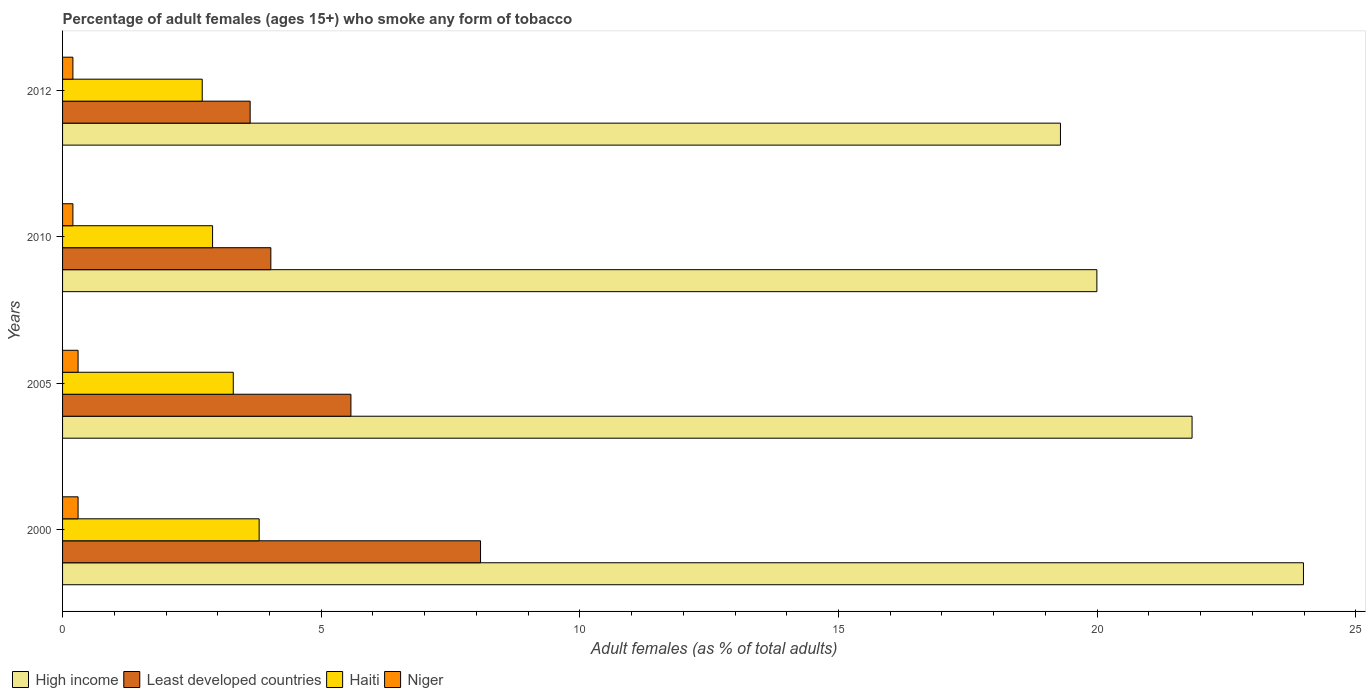How many different coloured bars are there?
Your response must be concise. 4. How many groups of bars are there?
Offer a very short reply. 4. Are the number of bars per tick equal to the number of legend labels?
Your answer should be very brief. Yes. Are the number of bars on each tick of the Y-axis equal?
Your answer should be very brief. Yes. What is the total percentage of adult females who smoke in Least developed countries in the graph?
Offer a very short reply. 21.31. What is the difference between the percentage of adult females who smoke in High income in 2010 and that in 2012?
Your answer should be compact. 0.7. What is the difference between the percentage of adult females who smoke in Least developed countries in 2010 and the percentage of adult females who smoke in Niger in 2000?
Your answer should be very brief. 3.73. What is the average percentage of adult females who smoke in Least developed countries per year?
Your response must be concise. 5.33. In the year 2010, what is the difference between the percentage of adult females who smoke in High income and percentage of adult females who smoke in Least developed countries?
Make the answer very short. 15.97. What is the ratio of the percentage of adult females who smoke in Least developed countries in 2000 to that in 2010?
Make the answer very short. 2.01. Is the percentage of adult females who smoke in Least developed countries in 2000 less than that in 2010?
Provide a succinct answer. No. What is the difference between the highest and the second highest percentage of adult females who smoke in High income?
Offer a terse response. 2.15. What is the difference between the highest and the lowest percentage of adult females who smoke in High income?
Your response must be concise. 4.7. In how many years, is the percentage of adult females who smoke in Haiti greater than the average percentage of adult females who smoke in Haiti taken over all years?
Offer a very short reply. 2. Is the sum of the percentage of adult females who smoke in Haiti in 2000 and 2010 greater than the maximum percentage of adult females who smoke in Niger across all years?
Keep it short and to the point. Yes. What does the 1st bar from the top in 2010 represents?
Offer a very short reply. Niger. What does the 4th bar from the bottom in 2010 represents?
Your answer should be compact. Niger. Is it the case that in every year, the sum of the percentage of adult females who smoke in High income and percentage of adult females who smoke in Least developed countries is greater than the percentage of adult females who smoke in Niger?
Your answer should be compact. Yes. Are the values on the major ticks of X-axis written in scientific E-notation?
Ensure brevity in your answer.  No. Does the graph contain any zero values?
Offer a very short reply. No. Does the graph contain grids?
Provide a succinct answer. No. Where does the legend appear in the graph?
Offer a terse response. Bottom left. How many legend labels are there?
Offer a very short reply. 4. What is the title of the graph?
Keep it short and to the point. Percentage of adult females (ages 15+) who smoke any form of tobacco. What is the label or title of the X-axis?
Offer a terse response. Adult females (as % of total adults). What is the Adult females (as % of total adults) in High income in 2000?
Provide a succinct answer. 23.99. What is the Adult females (as % of total adults) in Least developed countries in 2000?
Make the answer very short. 8.08. What is the Adult females (as % of total adults) in Niger in 2000?
Offer a terse response. 0.3. What is the Adult females (as % of total adults) in High income in 2005?
Your response must be concise. 21.83. What is the Adult females (as % of total adults) of Least developed countries in 2005?
Offer a very short reply. 5.57. What is the Adult females (as % of total adults) of Haiti in 2005?
Offer a very short reply. 3.3. What is the Adult females (as % of total adults) of High income in 2010?
Provide a short and direct response. 19.99. What is the Adult females (as % of total adults) in Least developed countries in 2010?
Offer a very short reply. 4.03. What is the Adult females (as % of total adults) in Haiti in 2010?
Ensure brevity in your answer.  2.9. What is the Adult females (as % of total adults) of Niger in 2010?
Give a very brief answer. 0.2. What is the Adult females (as % of total adults) in High income in 2012?
Your answer should be compact. 19.29. What is the Adult females (as % of total adults) of Least developed countries in 2012?
Make the answer very short. 3.63. What is the Adult females (as % of total adults) in Haiti in 2012?
Make the answer very short. 2.7. Across all years, what is the maximum Adult females (as % of total adults) in High income?
Your response must be concise. 23.99. Across all years, what is the maximum Adult females (as % of total adults) in Least developed countries?
Ensure brevity in your answer.  8.08. Across all years, what is the minimum Adult females (as % of total adults) of High income?
Offer a terse response. 19.29. Across all years, what is the minimum Adult females (as % of total adults) of Least developed countries?
Make the answer very short. 3.63. Across all years, what is the minimum Adult females (as % of total adults) of Haiti?
Provide a succinct answer. 2.7. Across all years, what is the minimum Adult females (as % of total adults) in Niger?
Your response must be concise. 0.2. What is the total Adult females (as % of total adults) in High income in the graph?
Offer a terse response. 85.11. What is the total Adult females (as % of total adults) of Least developed countries in the graph?
Your response must be concise. 21.31. What is the difference between the Adult females (as % of total adults) of High income in 2000 and that in 2005?
Provide a succinct answer. 2.15. What is the difference between the Adult females (as % of total adults) in Least developed countries in 2000 and that in 2005?
Give a very brief answer. 2.51. What is the difference between the Adult females (as % of total adults) of Haiti in 2000 and that in 2005?
Your answer should be very brief. 0.5. What is the difference between the Adult females (as % of total adults) in High income in 2000 and that in 2010?
Make the answer very short. 3.99. What is the difference between the Adult females (as % of total adults) in Least developed countries in 2000 and that in 2010?
Keep it short and to the point. 4.05. What is the difference between the Adult females (as % of total adults) of Haiti in 2000 and that in 2010?
Provide a short and direct response. 0.9. What is the difference between the Adult females (as % of total adults) in Niger in 2000 and that in 2010?
Offer a terse response. 0.1. What is the difference between the Adult females (as % of total adults) of High income in 2000 and that in 2012?
Give a very brief answer. 4.7. What is the difference between the Adult females (as % of total adults) of Least developed countries in 2000 and that in 2012?
Offer a terse response. 4.45. What is the difference between the Adult females (as % of total adults) in High income in 2005 and that in 2010?
Offer a terse response. 1.84. What is the difference between the Adult females (as % of total adults) of Least developed countries in 2005 and that in 2010?
Keep it short and to the point. 1.55. What is the difference between the Adult females (as % of total adults) in Haiti in 2005 and that in 2010?
Offer a terse response. 0.4. What is the difference between the Adult females (as % of total adults) in Niger in 2005 and that in 2010?
Offer a very short reply. 0.1. What is the difference between the Adult females (as % of total adults) in High income in 2005 and that in 2012?
Your answer should be very brief. 2.54. What is the difference between the Adult females (as % of total adults) in Least developed countries in 2005 and that in 2012?
Provide a succinct answer. 1.95. What is the difference between the Adult females (as % of total adults) in High income in 2010 and that in 2012?
Offer a terse response. 0.7. What is the difference between the Adult females (as % of total adults) in Least developed countries in 2010 and that in 2012?
Offer a very short reply. 0.4. What is the difference between the Adult females (as % of total adults) of Haiti in 2010 and that in 2012?
Provide a short and direct response. 0.2. What is the difference between the Adult females (as % of total adults) in Niger in 2010 and that in 2012?
Your response must be concise. 0. What is the difference between the Adult females (as % of total adults) of High income in 2000 and the Adult females (as % of total adults) of Least developed countries in 2005?
Provide a short and direct response. 18.41. What is the difference between the Adult females (as % of total adults) of High income in 2000 and the Adult females (as % of total adults) of Haiti in 2005?
Your answer should be very brief. 20.69. What is the difference between the Adult females (as % of total adults) in High income in 2000 and the Adult females (as % of total adults) in Niger in 2005?
Your response must be concise. 23.69. What is the difference between the Adult females (as % of total adults) of Least developed countries in 2000 and the Adult females (as % of total adults) of Haiti in 2005?
Your answer should be compact. 4.78. What is the difference between the Adult females (as % of total adults) in Least developed countries in 2000 and the Adult females (as % of total adults) in Niger in 2005?
Your response must be concise. 7.78. What is the difference between the Adult females (as % of total adults) in High income in 2000 and the Adult females (as % of total adults) in Least developed countries in 2010?
Offer a terse response. 19.96. What is the difference between the Adult females (as % of total adults) of High income in 2000 and the Adult females (as % of total adults) of Haiti in 2010?
Offer a very short reply. 21.09. What is the difference between the Adult females (as % of total adults) in High income in 2000 and the Adult females (as % of total adults) in Niger in 2010?
Offer a terse response. 23.79. What is the difference between the Adult females (as % of total adults) in Least developed countries in 2000 and the Adult females (as % of total adults) in Haiti in 2010?
Keep it short and to the point. 5.18. What is the difference between the Adult females (as % of total adults) of Least developed countries in 2000 and the Adult females (as % of total adults) of Niger in 2010?
Provide a short and direct response. 7.88. What is the difference between the Adult females (as % of total adults) in Haiti in 2000 and the Adult females (as % of total adults) in Niger in 2010?
Provide a short and direct response. 3.6. What is the difference between the Adult females (as % of total adults) of High income in 2000 and the Adult females (as % of total adults) of Least developed countries in 2012?
Provide a short and direct response. 20.36. What is the difference between the Adult females (as % of total adults) of High income in 2000 and the Adult females (as % of total adults) of Haiti in 2012?
Your answer should be compact. 21.29. What is the difference between the Adult females (as % of total adults) in High income in 2000 and the Adult females (as % of total adults) in Niger in 2012?
Your response must be concise. 23.79. What is the difference between the Adult females (as % of total adults) in Least developed countries in 2000 and the Adult females (as % of total adults) in Haiti in 2012?
Make the answer very short. 5.38. What is the difference between the Adult females (as % of total adults) in Least developed countries in 2000 and the Adult females (as % of total adults) in Niger in 2012?
Make the answer very short. 7.88. What is the difference between the Adult females (as % of total adults) of High income in 2005 and the Adult females (as % of total adults) of Least developed countries in 2010?
Provide a succinct answer. 17.81. What is the difference between the Adult females (as % of total adults) in High income in 2005 and the Adult females (as % of total adults) in Haiti in 2010?
Offer a very short reply. 18.93. What is the difference between the Adult females (as % of total adults) in High income in 2005 and the Adult females (as % of total adults) in Niger in 2010?
Provide a succinct answer. 21.63. What is the difference between the Adult females (as % of total adults) in Least developed countries in 2005 and the Adult females (as % of total adults) in Haiti in 2010?
Make the answer very short. 2.67. What is the difference between the Adult females (as % of total adults) in Least developed countries in 2005 and the Adult females (as % of total adults) in Niger in 2010?
Your answer should be compact. 5.37. What is the difference between the Adult females (as % of total adults) in High income in 2005 and the Adult females (as % of total adults) in Least developed countries in 2012?
Ensure brevity in your answer.  18.21. What is the difference between the Adult females (as % of total adults) in High income in 2005 and the Adult females (as % of total adults) in Haiti in 2012?
Your answer should be compact. 19.13. What is the difference between the Adult females (as % of total adults) of High income in 2005 and the Adult females (as % of total adults) of Niger in 2012?
Give a very brief answer. 21.63. What is the difference between the Adult females (as % of total adults) in Least developed countries in 2005 and the Adult females (as % of total adults) in Haiti in 2012?
Offer a terse response. 2.87. What is the difference between the Adult females (as % of total adults) of Least developed countries in 2005 and the Adult females (as % of total adults) of Niger in 2012?
Provide a succinct answer. 5.37. What is the difference between the Adult females (as % of total adults) in Haiti in 2005 and the Adult females (as % of total adults) in Niger in 2012?
Offer a terse response. 3.1. What is the difference between the Adult females (as % of total adults) in High income in 2010 and the Adult females (as % of total adults) in Least developed countries in 2012?
Offer a terse response. 16.37. What is the difference between the Adult females (as % of total adults) in High income in 2010 and the Adult females (as % of total adults) in Haiti in 2012?
Ensure brevity in your answer.  17.29. What is the difference between the Adult females (as % of total adults) in High income in 2010 and the Adult females (as % of total adults) in Niger in 2012?
Make the answer very short. 19.79. What is the difference between the Adult females (as % of total adults) in Least developed countries in 2010 and the Adult females (as % of total adults) in Haiti in 2012?
Your response must be concise. 1.33. What is the difference between the Adult females (as % of total adults) of Least developed countries in 2010 and the Adult females (as % of total adults) of Niger in 2012?
Offer a very short reply. 3.83. What is the difference between the Adult females (as % of total adults) in Haiti in 2010 and the Adult females (as % of total adults) in Niger in 2012?
Make the answer very short. 2.7. What is the average Adult females (as % of total adults) of High income per year?
Give a very brief answer. 21.28. What is the average Adult females (as % of total adults) in Least developed countries per year?
Offer a very short reply. 5.33. What is the average Adult females (as % of total adults) of Haiti per year?
Make the answer very short. 3.17. What is the average Adult females (as % of total adults) of Niger per year?
Keep it short and to the point. 0.25. In the year 2000, what is the difference between the Adult females (as % of total adults) of High income and Adult females (as % of total adults) of Least developed countries?
Offer a very short reply. 15.91. In the year 2000, what is the difference between the Adult females (as % of total adults) in High income and Adult females (as % of total adults) in Haiti?
Keep it short and to the point. 20.19. In the year 2000, what is the difference between the Adult females (as % of total adults) of High income and Adult females (as % of total adults) of Niger?
Your response must be concise. 23.69. In the year 2000, what is the difference between the Adult females (as % of total adults) of Least developed countries and Adult females (as % of total adults) of Haiti?
Offer a very short reply. 4.28. In the year 2000, what is the difference between the Adult females (as % of total adults) in Least developed countries and Adult females (as % of total adults) in Niger?
Offer a very short reply. 7.78. In the year 2000, what is the difference between the Adult females (as % of total adults) of Haiti and Adult females (as % of total adults) of Niger?
Keep it short and to the point. 3.5. In the year 2005, what is the difference between the Adult females (as % of total adults) in High income and Adult females (as % of total adults) in Least developed countries?
Give a very brief answer. 16.26. In the year 2005, what is the difference between the Adult females (as % of total adults) of High income and Adult females (as % of total adults) of Haiti?
Make the answer very short. 18.53. In the year 2005, what is the difference between the Adult females (as % of total adults) of High income and Adult females (as % of total adults) of Niger?
Provide a succinct answer. 21.53. In the year 2005, what is the difference between the Adult females (as % of total adults) of Least developed countries and Adult females (as % of total adults) of Haiti?
Keep it short and to the point. 2.27. In the year 2005, what is the difference between the Adult females (as % of total adults) in Least developed countries and Adult females (as % of total adults) in Niger?
Keep it short and to the point. 5.27. In the year 2010, what is the difference between the Adult females (as % of total adults) in High income and Adult females (as % of total adults) in Least developed countries?
Give a very brief answer. 15.97. In the year 2010, what is the difference between the Adult females (as % of total adults) of High income and Adult females (as % of total adults) of Haiti?
Offer a terse response. 17.09. In the year 2010, what is the difference between the Adult females (as % of total adults) in High income and Adult females (as % of total adults) in Niger?
Offer a very short reply. 19.79. In the year 2010, what is the difference between the Adult females (as % of total adults) in Least developed countries and Adult females (as % of total adults) in Haiti?
Give a very brief answer. 1.13. In the year 2010, what is the difference between the Adult females (as % of total adults) in Least developed countries and Adult females (as % of total adults) in Niger?
Offer a very short reply. 3.83. In the year 2010, what is the difference between the Adult females (as % of total adults) of Haiti and Adult females (as % of total adults) of Niger?
Give a very brief answer. 2.7. In the year 2012, what is the difference between the Adult females (as % of total adults) in High income and Adult females (as % of total adults) in Least developed countries?
Offer a terse response. 15.66. In the year 2012, what is the difference between the Adult females (as % of total adults) in High income and Adult females (as % of total adults) in Haiti?
Offer a very short reply. 16.59. In the year 2012, what is the difference between the Adult females (as % of total adults) in High income and Adult females (as % of total adults) in Niger?
Your answer should be very brief. 19.09. In the year 2012, what is the difference between the Adult females (as % of total adults) of Least developed countries and Adult females (as % of total adults) of Haiti?
Keep it short and to the point. 0.93. In the year 2012, what is the difference between the Adult females (as % of total adults) in Least developed countries and Adult females (as % of total adults) in Niger?
Your answer should be very brief. 3.43. What is the ratio of the Adult females (as % of total adults) of High income in 2000 to that in 2005?
Keep it short and to the point. 1.1. What is the ratio of the Adult females (as % of total adults) of Least developed countries in 2000 to that in 2005?
Give a very brief answer. 1.45. What is the ratio of the Adult females (as % of total adults) of Haiti in 2000 to that in 2005?
Ensure brevity in your answer.  1.15. What is the ratio of the Adult females (as % of total adults) of Niger in 2000 to that in 2005?
Provide a succinct answer. 1. What is the ratio of the Adult females (as % of total adults) of High income in 2000 to that in 2010?
Your answer should be compact. 1.2. What is the ratio of the Adult females (as % of total adults) in Least developed countries in 2000 to that in 2010?
Keep it short and to the point. 2.01. What is the ratio of the Adult females (as % of total adults) of Haiti in 2000 to that in 2010?
Provide a succinct answer. 1.31. What is the ratio of the Adult females (as % of total adults) in High income in 2000 to that in 2012?
Offer a very short reply. 1.24. What is the ratio of the Adult females (as % of total adults) in Least developed countries in 2000 to that in 2012?
Your answer should be compact. 2.23. What is the ratio of the Adult females (as % of total adults) in Haiti in 2000 to that in 2012?
Your answer should be very brief. 1.41. What is the ratio of the Adult females (as % of total adults) in High income in 2005 to that in 2010?
Provide a succinct answer. 1.09. What is the ratio of the Adult females (as % of total adults) of Least developed countries in 2005 to that in 2010?
Provide a short and direct response. 1.38. What is the ratio of the Adult females (as % of total adults) in Haiti in 2005 to that in 2010?
Offer a terse response. 1.14. What is the ratio of the Adult females (as % of total adults) in High income in 2005 to that in 2012?
Keep it short and to the point. 1.13. What is the ratio of the Adult females (as % of total adults) in Least developed countries in 2005 to that in 2012?
Keep it short and to the point. 1.54. What is the ratio of the Adult females (as % of total adults) in Haiti in 2005 to that in 2012?
Ensure brevity in your answer.  1.22. What is the ratio of the Adult females (as % of total adults) of High income in 2010 to that in 2012?
Ensure brevity in your answer.  1.04. What is the ratio of the Adult females (as % of total adults) in Least developed countries in 2010 to that in 2012?
Your answer should be compact. 1.11. What is the ratio of the Adult females (as % of total adults) in Haiti in 2010 to that in 2012?
Make the answer very short. 1.07. What is the difference between the highest and the second highest Adult females (as % of total adults) in High income?
Keep it short and to the point. 2.15. What is the difference between the highest and the second highest Adult females (as % of total adults) of Least developed countries?
Give a very brief answer. 2.51. What is the difference between the highest and the second highest Adult females (as % of total adults) of Niger?
Provide a short and direct response. 0. What is the difference between the highest and the lowest Adult females (as % of total adults) of High income?
Your answer should be very brief. 4.7. What is the difference between the highest and the lowest Adult females (as % of total adults) in Least developed countries?
Provide a short and direct response. 4.45. What is the difference between the highest and the lowest Adult females (as % of total adults) of Haiti?
Provide a short and direct response. 1.1. What is the difference between the highest and the lowest Adult females (as % of total adults) in Niger?
Your answer should be very brief. 0.1. 